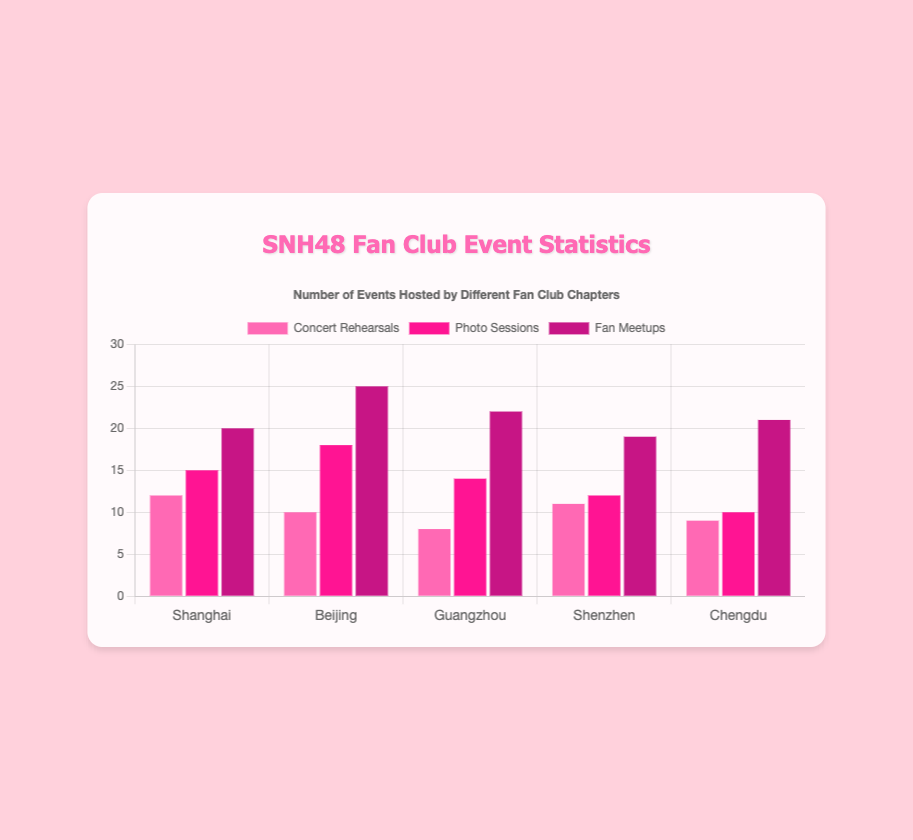What's the total number of fan meetups in all chapters? Sum up the fan meetups for all chapters: 20 (Shanghai) + 25 (Beijing) + 22 (Guangzhou) + 19 (Shenzhen) + 21 (Chengdu) = 107
Answer: 107 Which chapter hosted the most photo sessions? Look at the values for photo sessions across all chapters: Shanghai (15), Beijing (18), Guangzhou (14), Shenzhen (12), and Chengdu (10). The highest number is 18, hosted by the Beijing chapter
Answer: Beijing How many more concert rehearsals were hosted by Shanghai compared to Guangzhou? Subtract the number of concert rehearsals in Guangzhou (8) from that in Shanghai (12): 12 - 8 = 4
Answer: 4 What's the average number of events (concert rehearsals, photo sessions, fan meetups) hosted by the Shenzhen chapter? Add up all events for Shenzhen: 11 (concert rehearsals) + 12 (photo sessions) + 19 (fan meetups) = 42, then divide by the number of event types (3): 42 / 3 = 14
Answer: 14 Which chapter hosted the least number of concert rehearsals? Look at the values for concert rehearsals across all chapters: Shanghai (12), Beijing (10), Guangzhou (8), Shenzhen (11), and Chengdu (9). The smallest number is 8, hosted by the Guangzhou chapter
Answer: Guangzhou How many total events (concert rehearsals, photo sessions, fan meetups) were hosted by the Chengdu chapter? Add up all events for Chengdu: 9 (concert rehearsals) + 10 (photo sessions) + 21 (fan meetups) = 40
Answer: 40 Which event type had the highest total count across all chapters? Add up each event type across all chapters: Concert rehearsals (12+10+8+11+9=50), Photo sessions (15+18+14+12+10=69), Fan meetups (20+25+22+19+21=107). The highest total count is for fan meetups (107)
Answer: Fan meetups How many fewer photo sessions were hosted by Chengdu compared to Shanghai? Subtract the number of photo sessions in Chengdu (10) from that in Shanghai (15): 15 - 10 = 5
Answer: 5 What's the total number of photo sessions and fan meetups in the Beijing chapter? Add the number of photo sessions and fan meetups in Beijing: 18 (photo sessions) + 25 (fan meetups) = 43
Answer: 43 